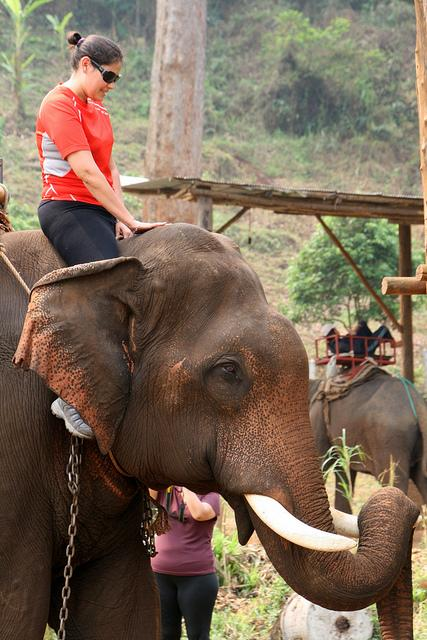Why is there a chain on the elephant?

Choices:
A) it's dangerous
B) it's injured
C) it's property
D) it's stylish it's property 